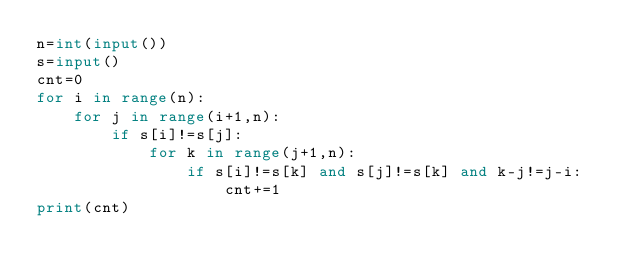<code> <loc_0><loc_0><loc_500><loc_500><_Python_>n=int(input())
s=input()
cnt=0
for i in range(n):
    for j in range(i+1,n):
        if s[i]!=s[j]:
            for k in range(j+1,n):
                if s[i]!=s[k] and s[j]!=s[k] and k-j!=j-i:
                    cnt+=1
print(cnt)
        </code> 